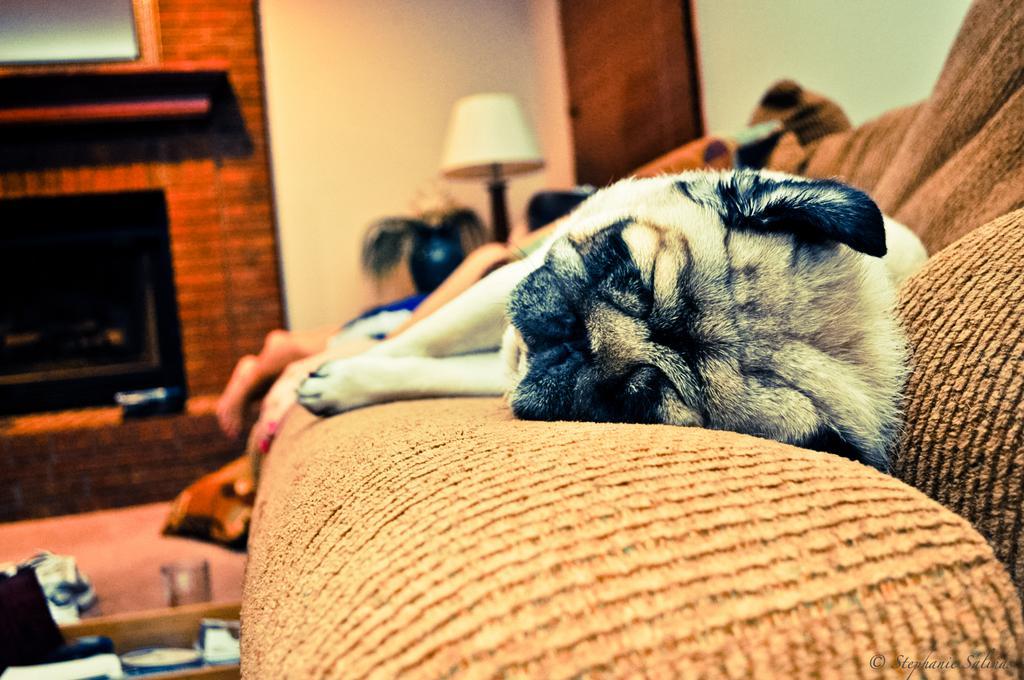Describe this image in one or two sentences. In this image I see a couch and I see a dog which is sleeping on it and I see a lamp over here and I see things over here. In the background I see the wall and I see a blue color thing over here. 